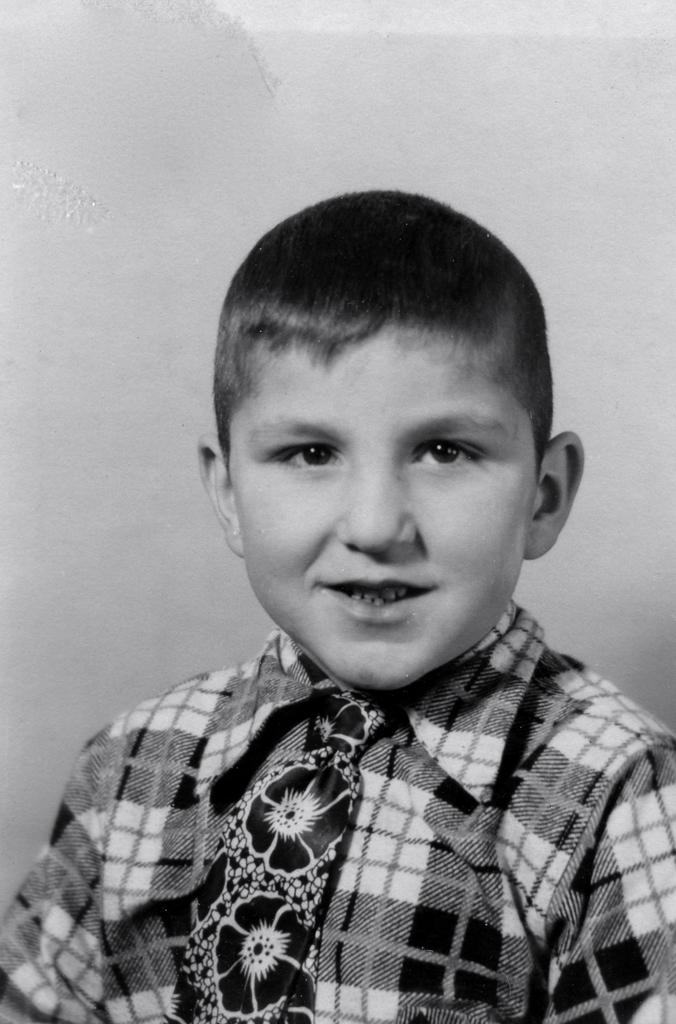What type of picture is in the image? The image contains a black and white picture of a boy. What can be seen on the boy's body in the picture? The boy is wearing clothes in the picture. What specific clothing item is the boy wearing in the picture? The boy is wearing a tie in the picture. What type of clam is visible in the picture? There is no clam present in the picture; it features a black and white picture of a boy. How does the boy establish a connection with the viewer in the picture? The picture does not show the boy interacting with the viewer, so it cannot be determined how he establishes a connection. 